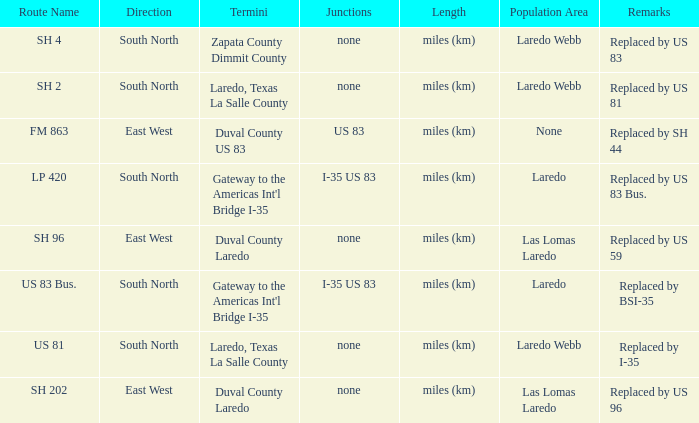Which junctions have "replaced by bsi-35" listed in their remarks section? I-35 US 83. 